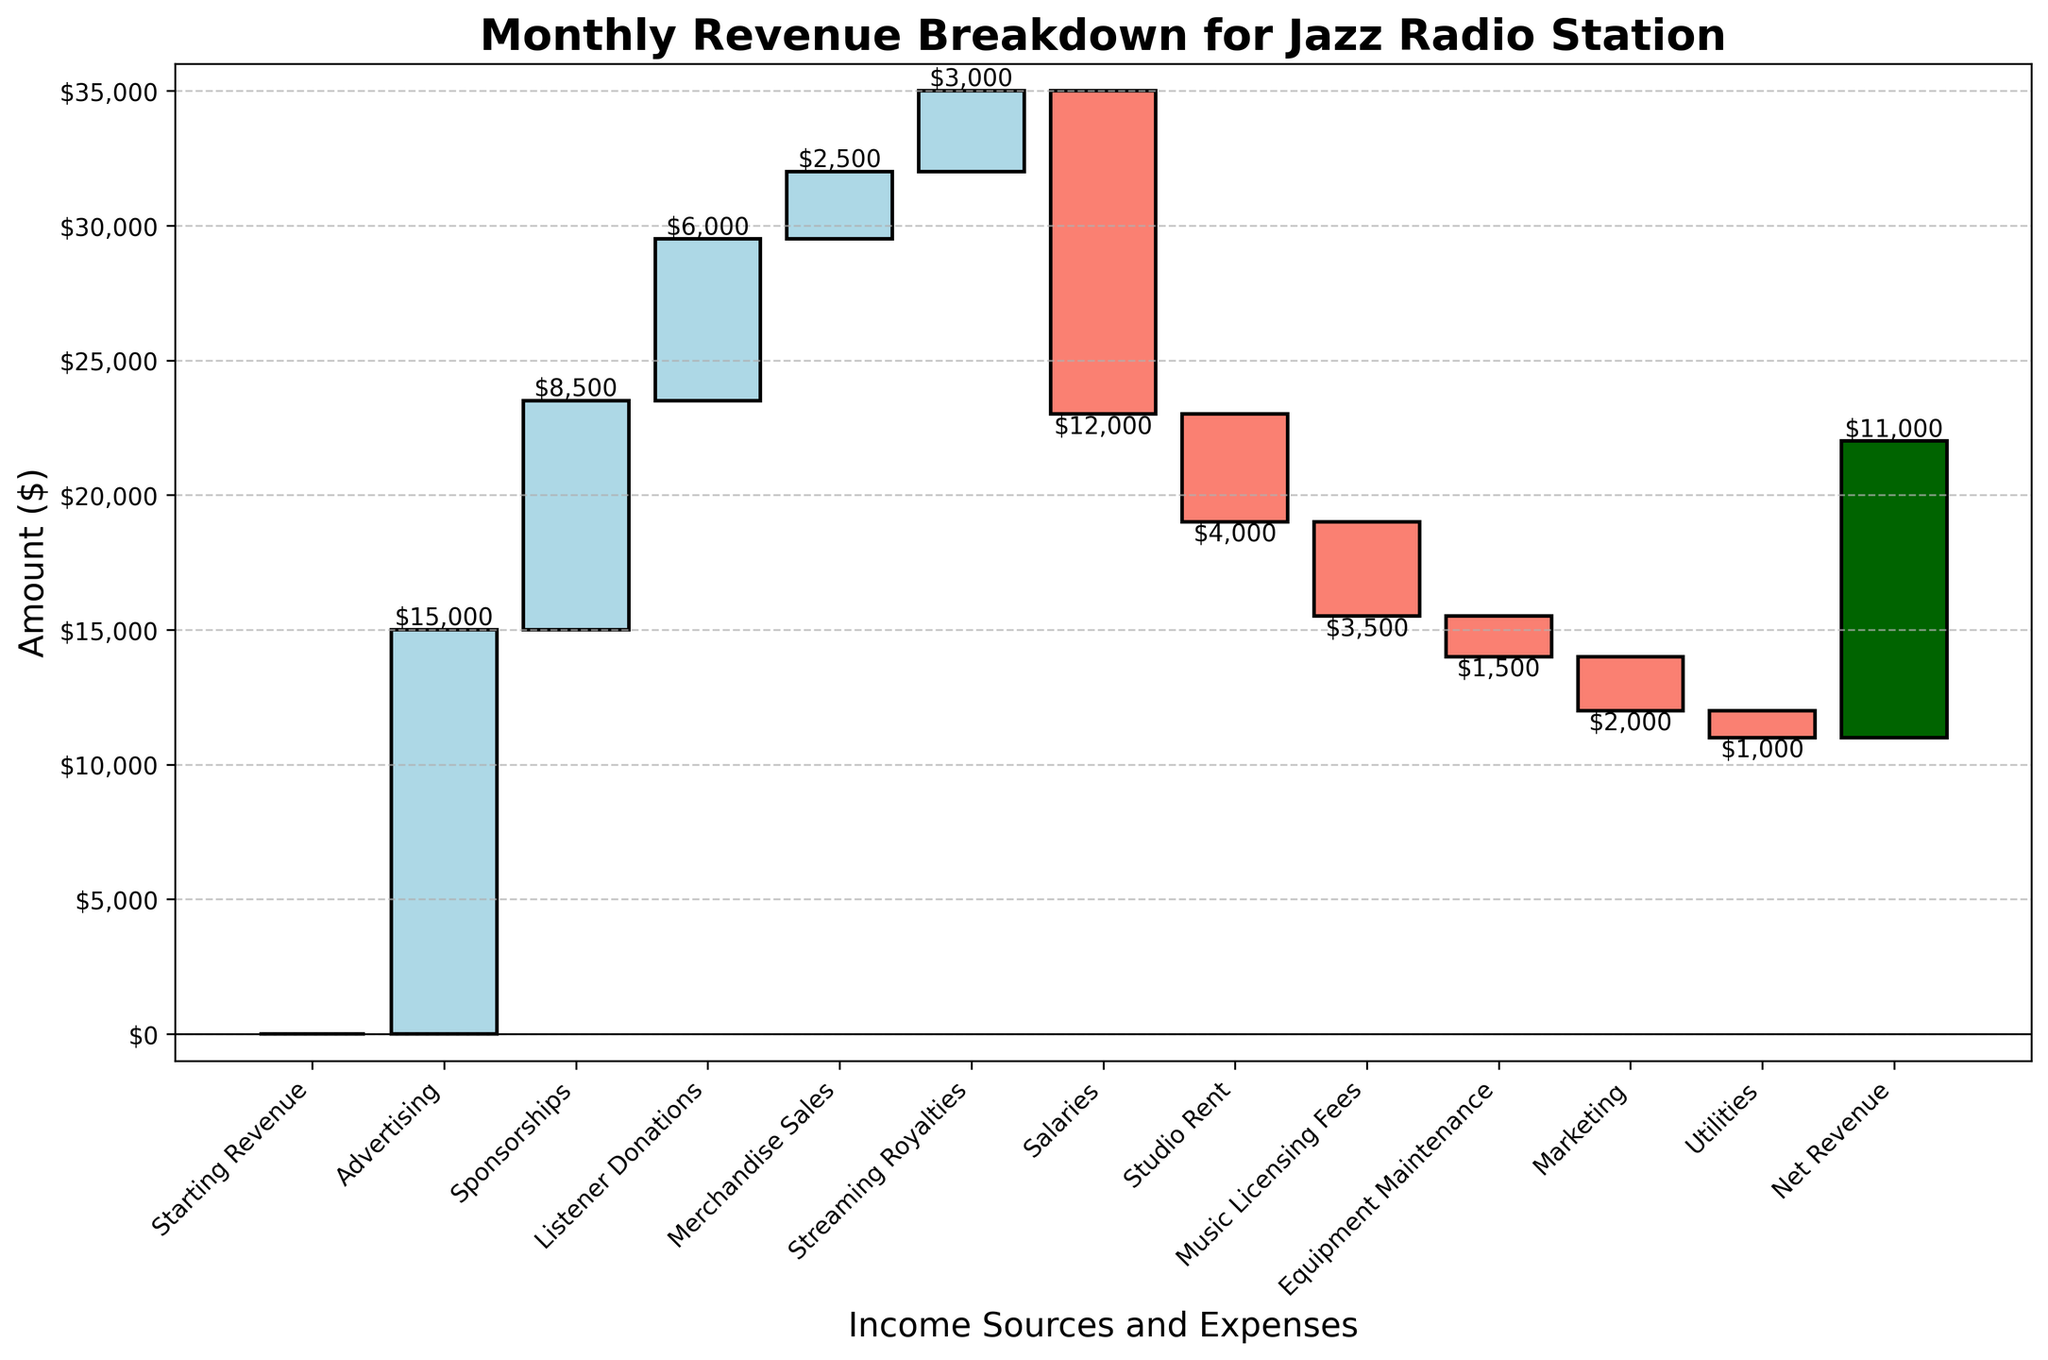What is the title of the chart? The title of the chart is located at the top and reads "Monthly Revenue Breakdown for Jazz Radio Station".
Answer: Monthly Revenue Breakdown for Jazz Radio Station What is the total amount of sponsorships received? The bar labeled "Sponsorships" shows a positive value of $8,500.
Answer: $8,500 Which category has the largest expense? The bar labeled "Salaries" shows the largest negative value, which is $12,000.
Answer: Salaries What is the net revenue at the end? The last bar labeled "Net Revenue" shows a positive value of $11,000.
Answer: $11,000 How much is the total income from advertising and listener donations combined? Add the values of the "Advertising" ($15,000) and "Listener Donations" ($6,000) bars: 15,000 + 6,000 = 21,000.
Answer: $21,000 What is the overall impact of merchandise sales and marketing expenses on the revenue? Merchandise Sales add $2,500 and Marketing subtracts $2,000. Combined, the impact is 2,500 - 2,000 = 500.
Answer: $500 By how much does the revenue decrease due to studio rent and equipment maintenance? Studio Rent is -$4,000 and Equipment Maintenance is -$1,500. Their combined impact is -4,000 - 1,500 = -5,500.
Answer: $5,500 Which category contributes more positively to the revenue, streaming royalties or listener donations? Compare the values of "Streaming Royalties" ($3,000) and "Listener Donations" ($6,000); Listener Donations is higher.
Answer: Listener Donations What is the net change in revenue due to operating expenses? Sum the amounts of operating expenses: Salaries (-$12,000), Studio Rent (-$4,000), Music Licensing Fees (-$3,500), Equipment Maintenance (-$1,500), Marketing (-$2,000), and Utilities (-$1,000). The net change is -12,000 - 4,000 - 3,500 - 1,500 - 2,000 - 1,000 = -24,000.
Answer: $24,000 How does the starting revenue compare to the net revenue? The "Starting Revenue" is $0 and the "Net Revenue" is $11,000. The difference is 11,000 - 0 = 11,000.
Answer: $11,000 